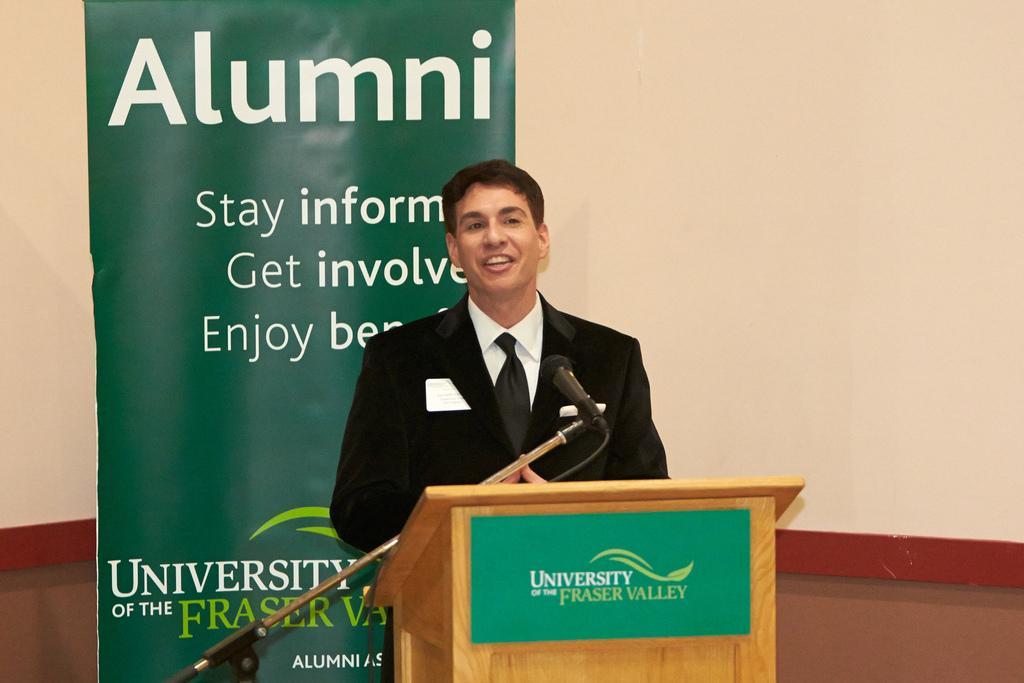Can you describe this image briefly? In the picture we can see a person wearing black color suit standing behind wooden podium and there is microphone and in the background of the picture there is green color sheet on which some words are written and there is a wall. 